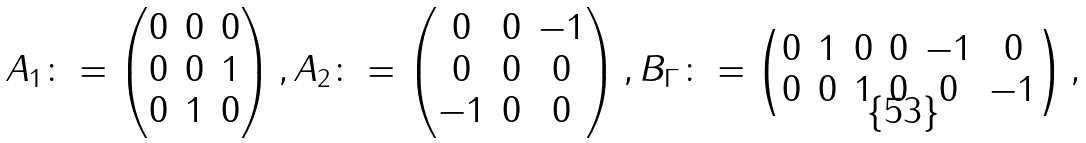Convert formula to latex. <formula><loc_0><loc_0><loc_500><loc_500>A _ { 1 } & \colon = \begin{pmatrix} 0 & 0 & 0 \\ 0 & 0 & 1 \\ 0 & 1 & 0 \end{pmatrix} , A _ { 2 } \colon = \begin{pmatrix} 0 & 0 & - 1 \\ 0 & 0 & 0 \\ - 1 & 0 & 0 \end{pmatrix} , B _ { \Gamma } \colon = \begin{pmatrix} 0 & 1 & 0 & 0 & - 1 & 0 \\ 0 & 0 & 1 & 0 & 0 & - 1 \end{pmatrix} ,</formula> 